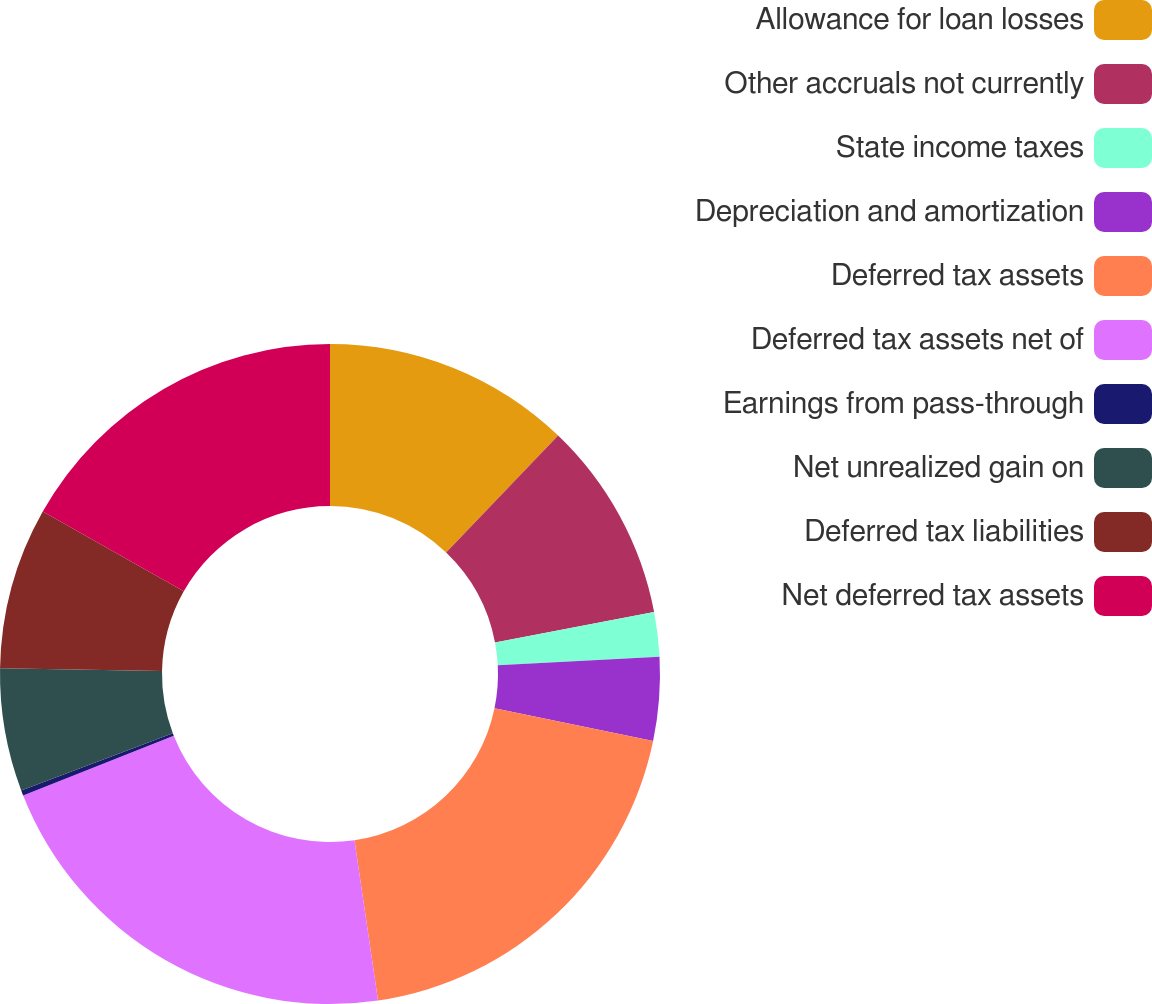Convert chart. <chart><loc_0><loc_0><loc_500><loc_500><pie_chart><fcel>Allowance for loan losses<fcel>Other accruals not currently<fcel>State income taxes<fcel>Depreciation and amortization<fcel>Deferred tax assets<fcel>Deferred tax assets net of<fcel>Earnings from pass-through<fcel>Net unrealized gain on<fcel>Deferred tax liabilities<fcel>Net deferred tax assets<nl><fcel>12.15%<fcel>9.84%<fcel>2.18%<fcel>4.09%<fcel>19.42%<fcel>21.33%<fcel>0.26%<fcel>6.01%<fcel>7.92%<fcel>16.81%<nl></chart> 